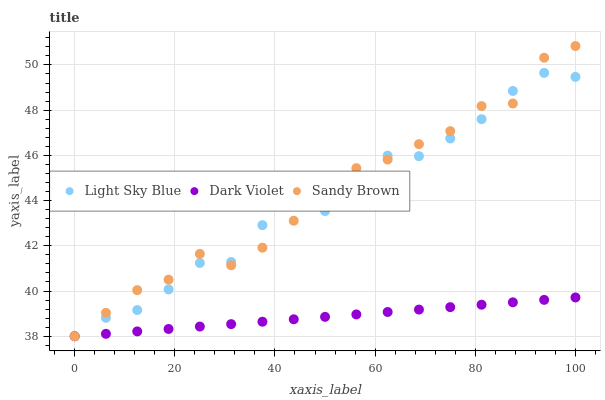Does Dark Violet have the minimum area under the curve?
Answer yes or no. Yes. Does Sandy Brown have the maximum area under the curve?
Answer yes or no. Yes. Does Sandy Brown have the minimum area under the curve?
Answer yes or no. No. Does Dark Violet have the maximum area under the curve?
Answer yes or no. No. Is Dark Violet the smoothest?
Answer yes or no. Yes. Is Light Sky Blue the roughest?
Answer yes or no. Yes. Is Sandy Brown the smoothest?
Answer yes or no. No. Is Sandy Brown the roughest?
Answer yes or no. No. Does Light Sky Blue have the lowest value?
Answer yes or no. Yes. Does Sandy Brown have the highest value?
Answer yes or no. Yes. Does Dark Violet have the highest value?
Answer yes or no. No. Does Light Sky Blue intersect Sandy Brown?
Answer yes or no. Yes. Is Light Sky Blue less than Sandy Brown?
Answer yes or no. No. Is Light Sky Blue greater than Sandy Brown?
Answer yes or no. No. 